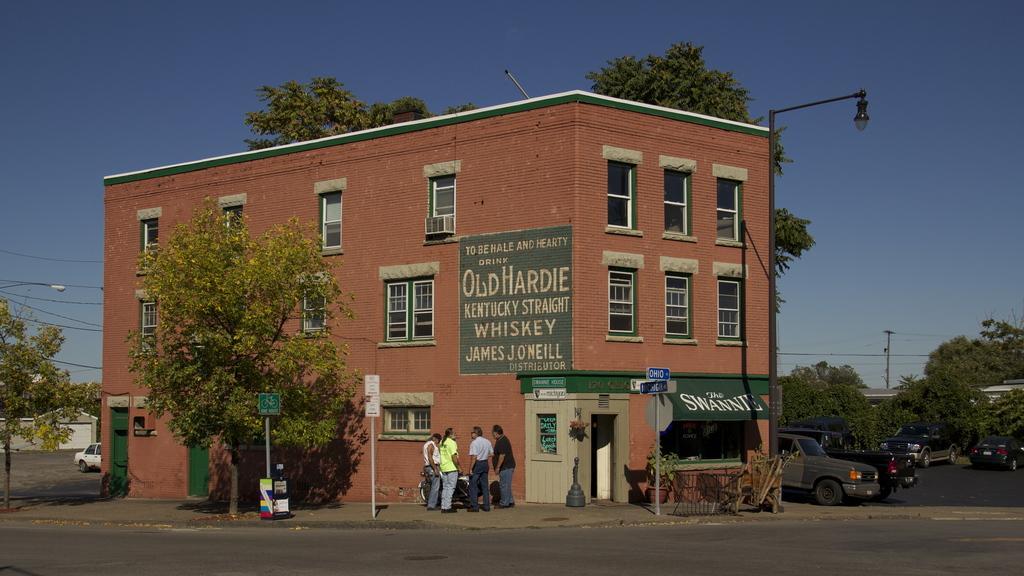Can you describe this image briefly? In this image I can see the road. To the side of the road there are boards to the pole and trees. I can also see many vehicles on the road. There are few people standing and wearing the different color dresses. These people are in-front of the bike. To the side there is a building which is in brown color and there are many windows to it. In the background I can see the blue sky. 